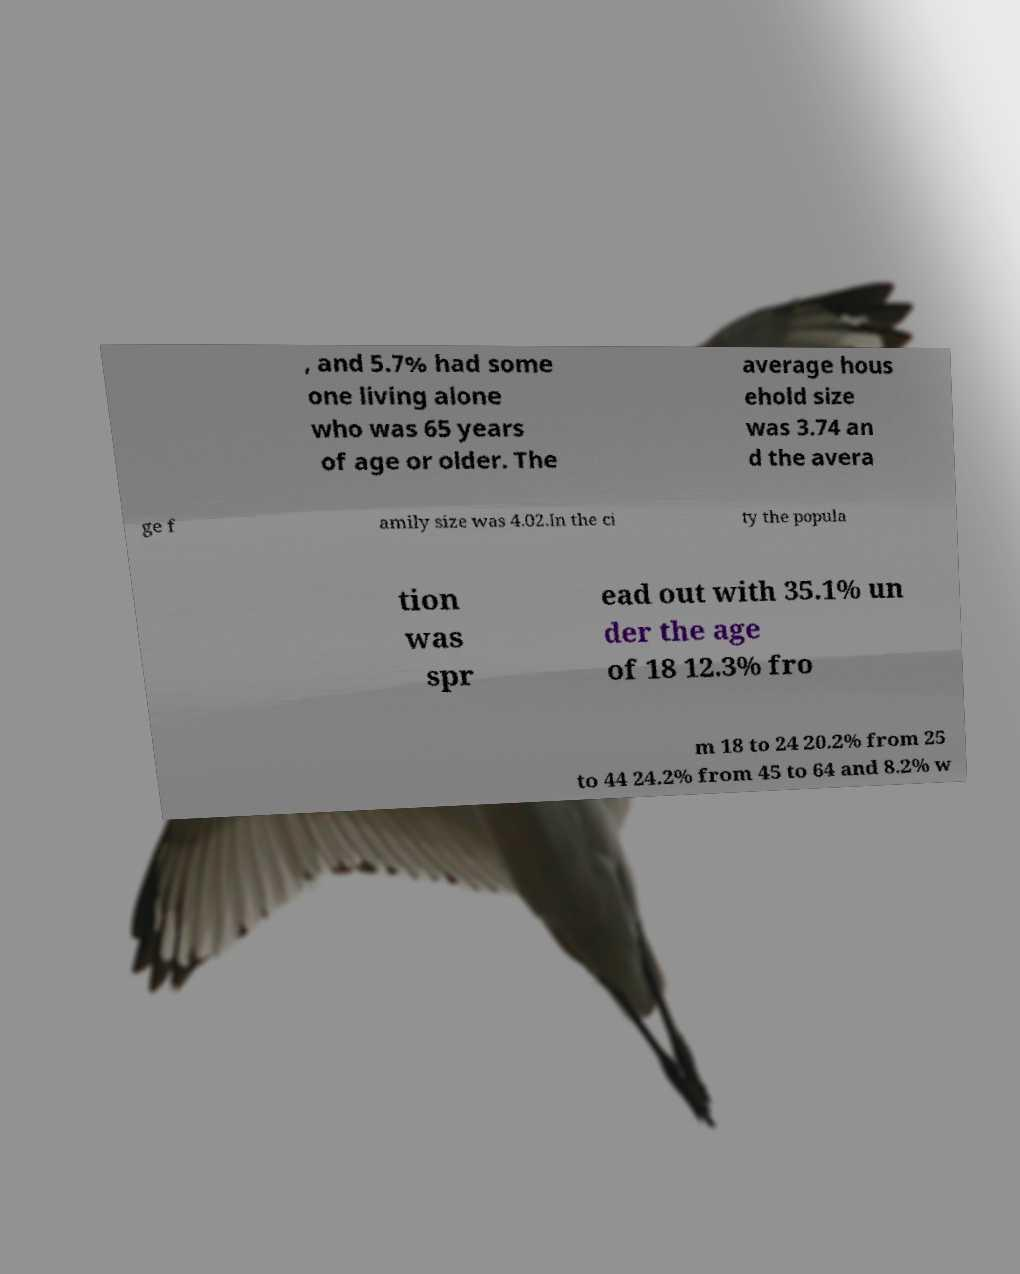Please identify and transcribe the text found in this image. , and 5.7% had some one living alone who was 65 years of age or older. The average hous ehold size was 3.74 an d the avera ge f amily size was 4.02.In the ci ty the popula tion was spr ead out with 35.1% un der the age of 18 12.3% fro m 18 to 24 20.2% from 25 to 44 24.2% from 45 to 64 and 8.2% w 